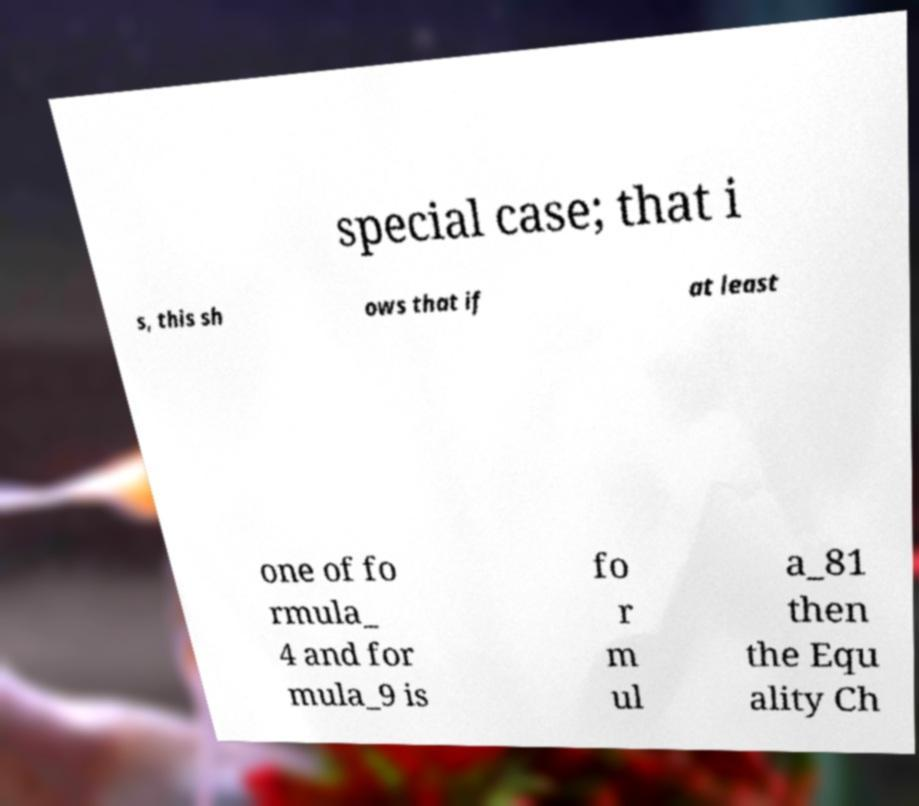Could you assist in decoding the text presented in this image and type it out clearly? special case; that i s, this sh ows that if at least one of fo rmula_ 4 and for mula_9 is fo r m ul a_81 then the Equ ality Ch 